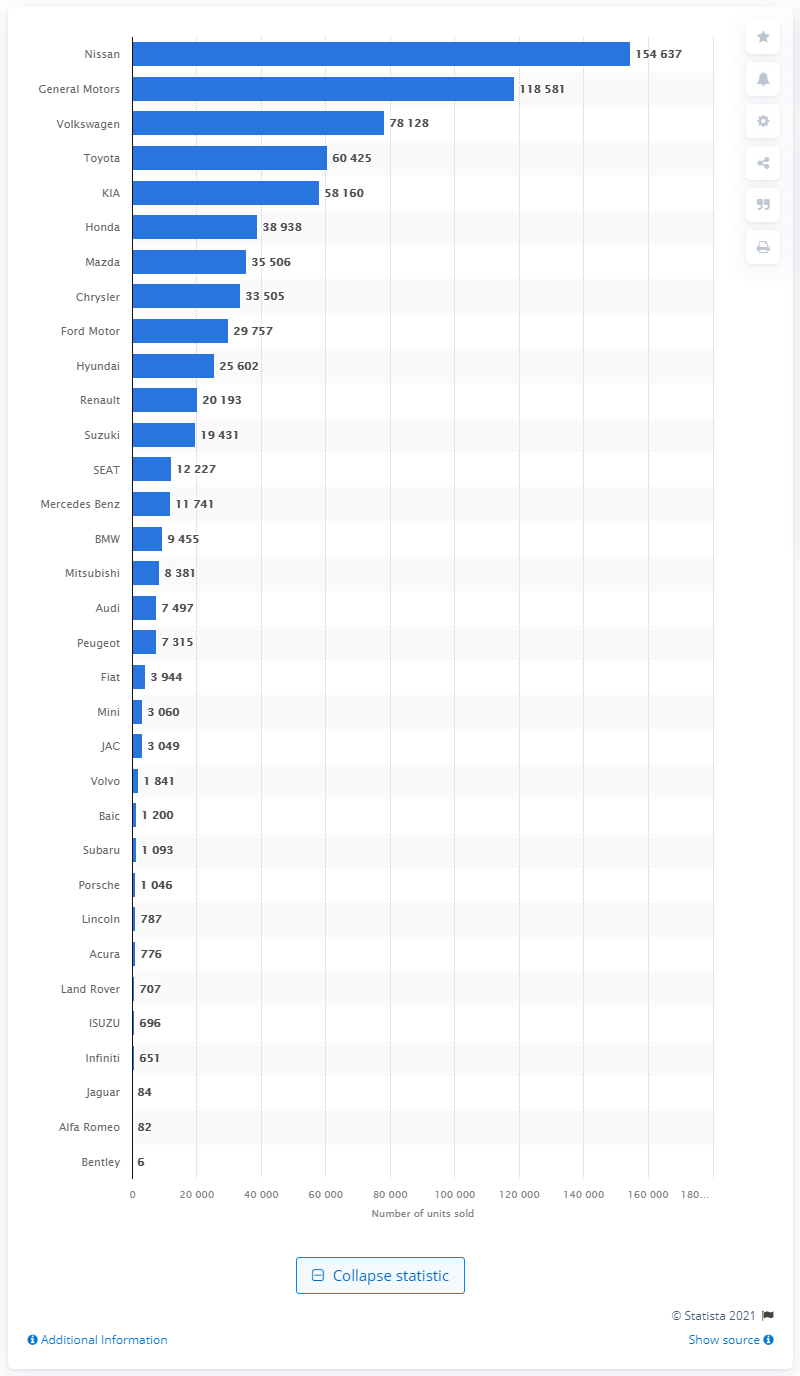Specify some key components in this picture. Nissan was the automobile manufacturer with the highest number of light vehicles sold in Mexico in 2020. In October 2020, Nissan sold a total of 154,637 light vehicles in Mexico. In 2020, General Motors sold a total of 118,581 light vehicle units. 